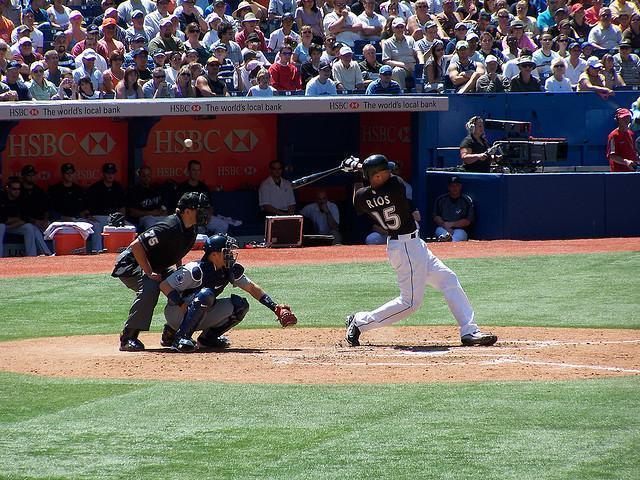How many people are in the photo?
Give a very brief answer. 4. How many white toilets with brown lids are in this image?
Give a very brief answer. 0. 